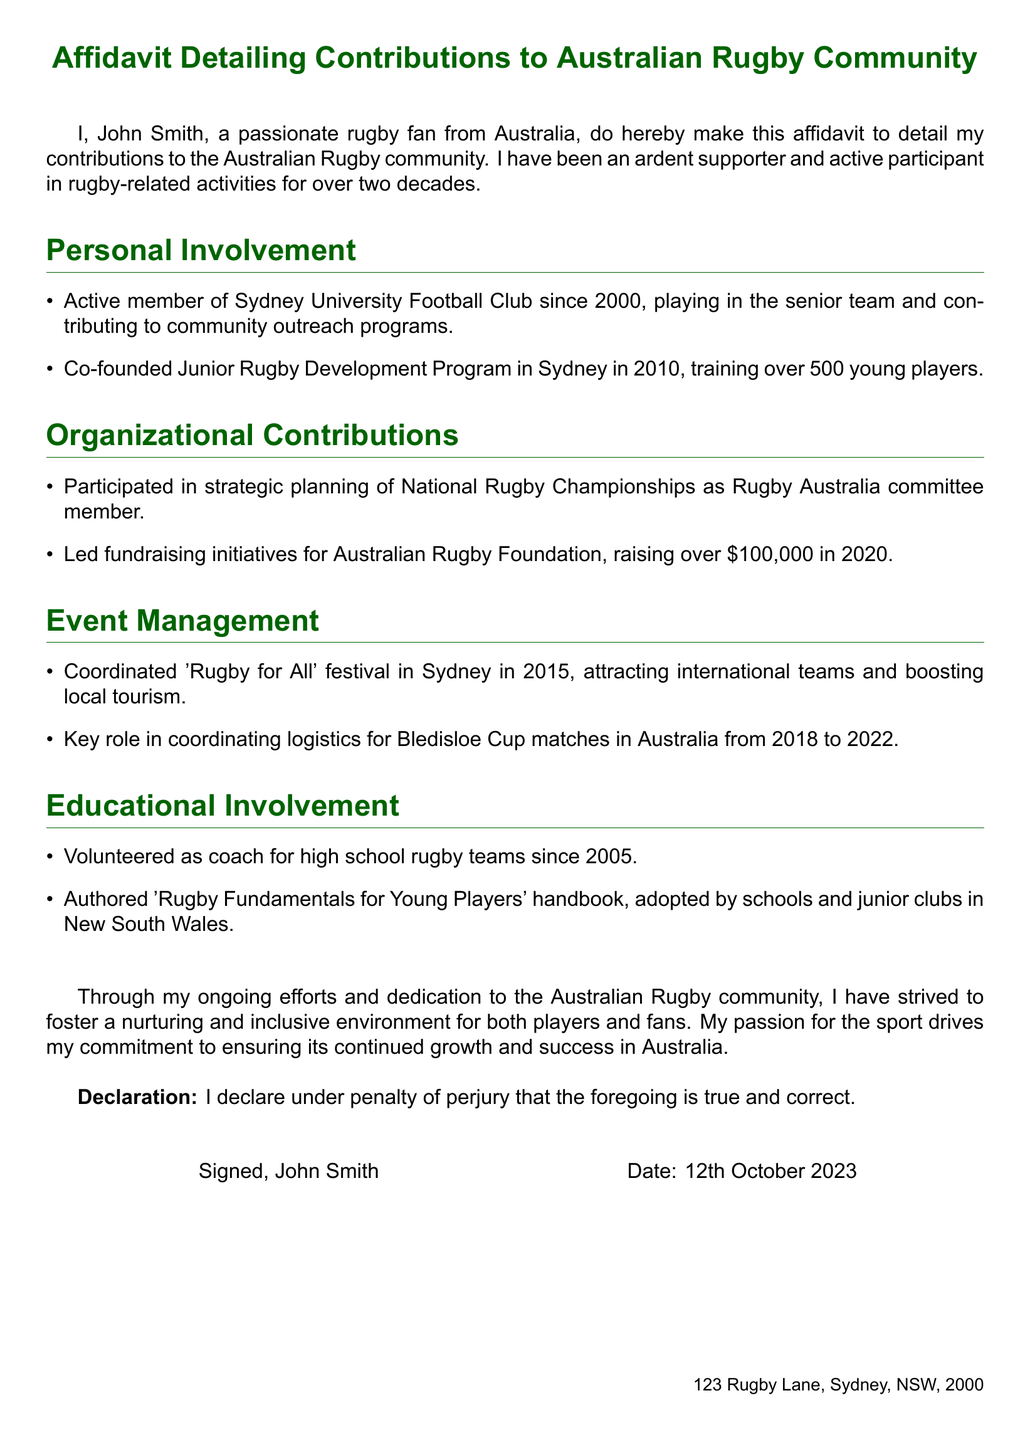What is the name of the affiant? The affiant is the individual making the affidavit, which is stated at the beginning.
Answer: John Smith In what year did John Smith start being an active member of Sydney University Football Club? The year he started is explicitly mentioned under the Personal Involvement section.
Answer: 2000 How much money was raised for the Australian Rugby Foundation in 2020? The exact amount raised for the foundation is specified under the Organizational Contributions section.
Answer: $100,000 What initiative did John Smith co-found in 2010? This initiative is mentioned in the Personal Involvement section.
Answer: Junior Rugby Development Program What document did John Smith author for young players? It is mentioned under the Educational Involvement section as a specific contribution.
Answer: Rugby Fundamentals for Young Players Which festival did John Smith coordinate in 2015? The festival is indicated in the Event Management section.
Answer: Rugby for All From which years did John Smith coordinate logistics for Bledisloe Cup matches? The years are stated in the Event Management section.
Answer: 2018 to 2022 Under what penalty does John Smith declare the affidavit's truthfulness? This is a specific phrasing found in the declaration section of the affidavit.
Answer: Penalty of perjury What city is John Smith's address located in? The address at the bottom provides this detail.
Answer: Sydney 